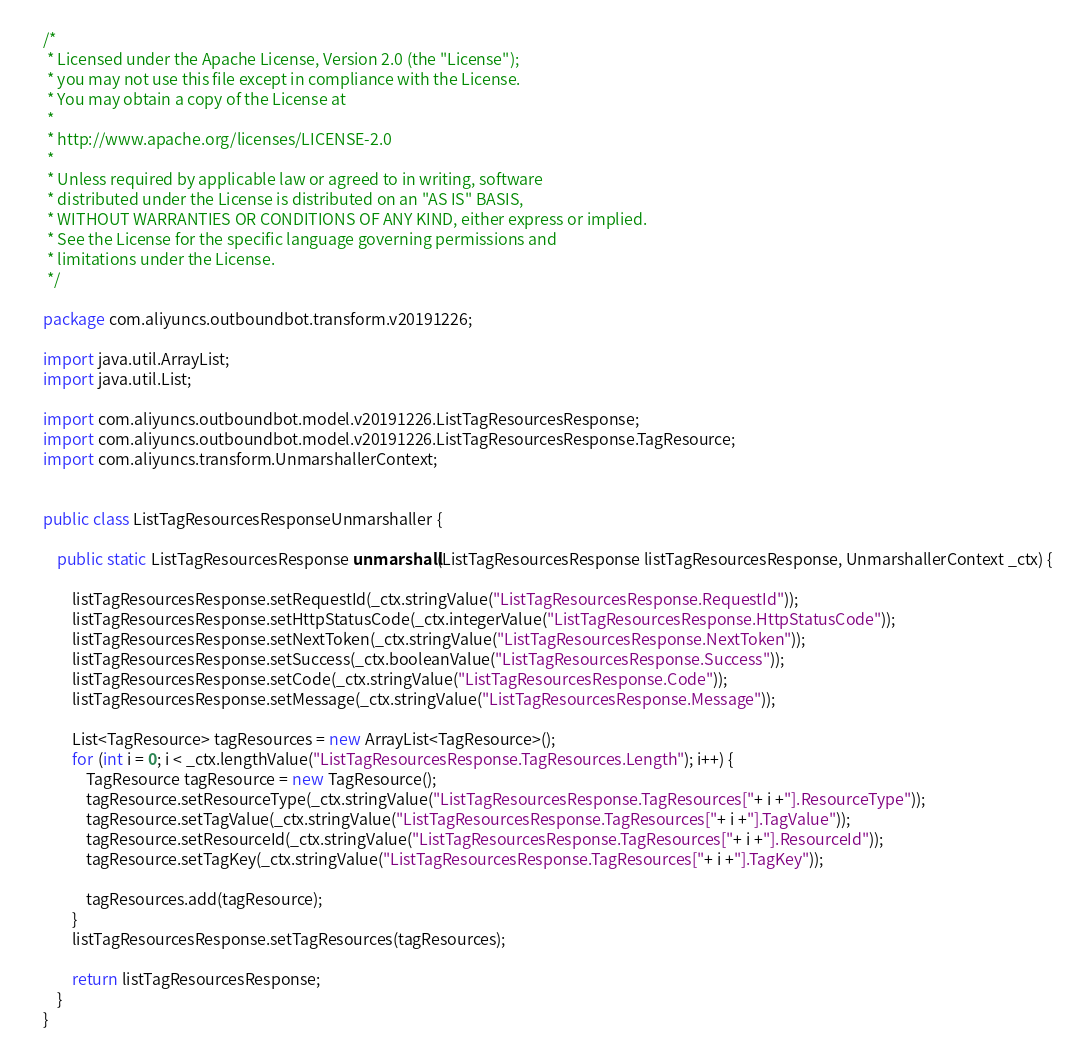Convert code to text. <code><loc_0><loc_0><loc_500><loc_500><_Java_>/*
 * Licensed under the Apache License, Version 2.0 (the "License");
 * you may not use this file except in compliance with the License.
 * You may obtain a copy of the License at
 *
 * http://www.apache.org/licenses/LICENSE-2.0
 *
 * Unless required by applicable law or agreed to in writing, software
 * distributed under the License is distributed on an "AS IS" BASIS,
 * WITHOUT WARRANTIES OR CONDITIONS OF ANY KIND, either express or implied.
 * See the License for the specific language governing permissions and
 * limitations under the License.
 */

package com.aliyuncs.outboundbot.transform.v20191226;

import java.util.ArrayList;
import java.util.List;

import com.aliyuncs.outboundbot.model.v20191226.ListTagResourcesResponse;
import com.aliyuncs.outboundbot.model.v20191226.ListTagResourcesResponse.TagResource;
import com.aliyuncs.transform.UnmarshallerContext;


public class ListTagResourcesResponseUnmarshaller {

	public static ListTagResourcesResponse unmarshall(ListTagResourcesResponse listTagResourcesResponse, UnmarshallerContext _ctx) {
		
		listTagResourcesResponse.setRequestId(_ctx.stringValue("ListTagResourcesResponse.RequestId"));
		listTagResourcesResponse.setHttpStatusCode(_ctx.integerValue("ListTagResourcesResponse.HttpStatusCode"));
		listTagResourcesResponse.setNextToken(_ctx.stringValue("ListTagResourcesResponse.NextToken"));
		listTagResourcesResponse.setSuccess(_ctx.booleanValue("ListTagResourcesResponse.Success"));
		listTagResourcesResponse.setCode(_ctx.stringValue("ListTagResourcesResponse.Code"));
		listTagResourcesResponse.setMessage(_ctx.stringValue("ListTagResourcesResponse.Message"));

		List<TagResource> tagResources = new ArrayList<TagResource>();
		for (int i = 0; i < _ctx.lengthValue("ListTagResourcesResponse.TagResources.Length"); i++) {
			TagResource tagResource = new TagResource();
			tagResource.setResourceType(_ctx.stringValue("ListTagResourcesResponse.TagResources["+ i +"].ResourceType"));
			tagResource.setTagValue(_ctx.stringValue("ListTagResourcesResponse.TagResources["+ i +"].TagValue"));
			tagResource.setResourceId(_ctx.stringValue("ListTagResourcesResponse.TagResources["+ i +"].ResourceId"));
			tagResource.setTagKey(_ctx.stringValue("ListTagResourcesResponse.TagResources["+ i +"].TagKey"));

			tagResources.add(tagResource);
		}
		listTagResourcesResponse.setTagResources(tagResources);
	 
	 	return listTagResourcesResponse;
	}
}</code> 